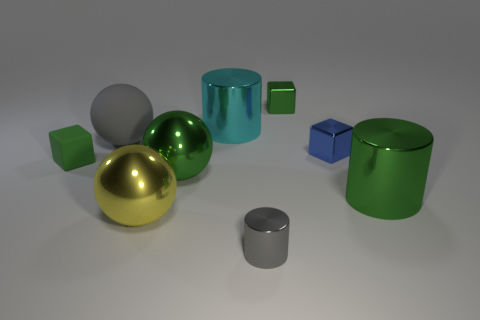How many green things are both right of the yellow metal ball and in front of the cyan shiny thing?
Provide a short and direct response. 2. Is there a gray cylinder that has the same material as the tiny blue cube?
Your answer should be very brief. Yes. There is a metallic cylinder that is the same color as the tiny rubber block; what size is it?
Keep it short and to the point. Large. What number of balls are either blue metallic things or tiny gray things?
Provide a short and direct response. 0. How big is the green metallic ball?
Keep it short and to the point. Large. There is a gray rubber thing; what number of cyan metallic objects are right of it?
Your answer should be compact. 1. What size is the green metallic thing that is behind the cylinder behind the green matte object?
Your response must be concise. Small. Is the shape of the gray object in front of the blue thing the same as the small green object that is in front of the green metal block?
Provide a succinct answer. No. There is a big yellow object in front of the metal sphere right of the yellow thing; what is its shape?
Your answer should be compact. Sphere. How big is the metallic cylinder that is behind the tiny gray cylinder and in front of the blue block?
Offer a very short reply. Large. 